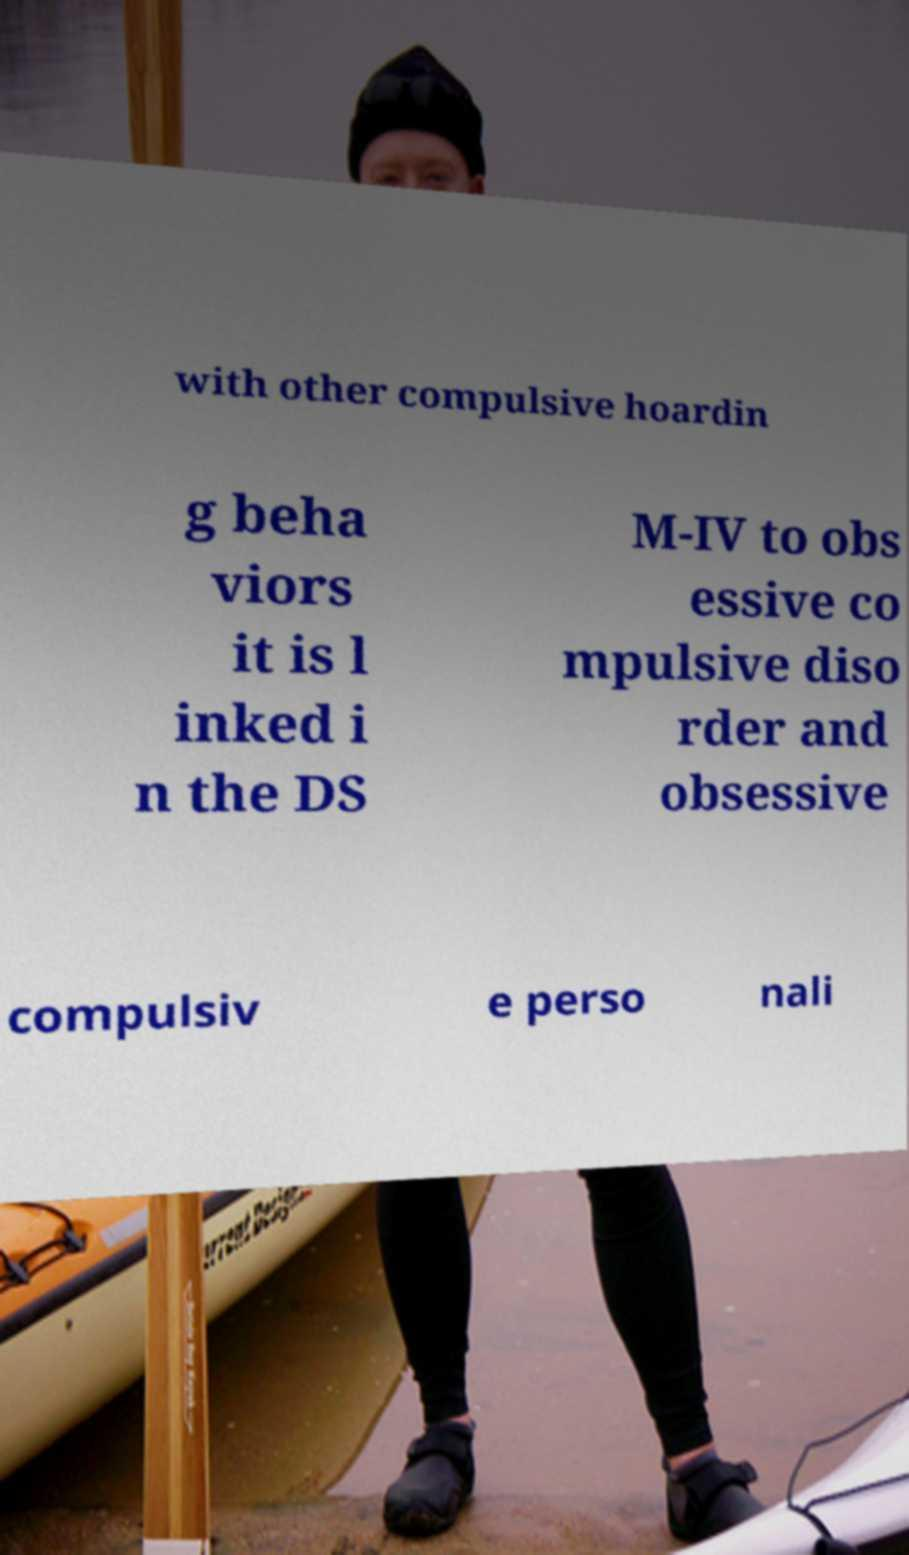Can you accurately transcribe the text from the provided image for me? with other compulsive hoardin g beha viors it is l inked i n the DS M-IV to obs essive co mpulsive diso rder and obsessive compulsiv e perso nali 